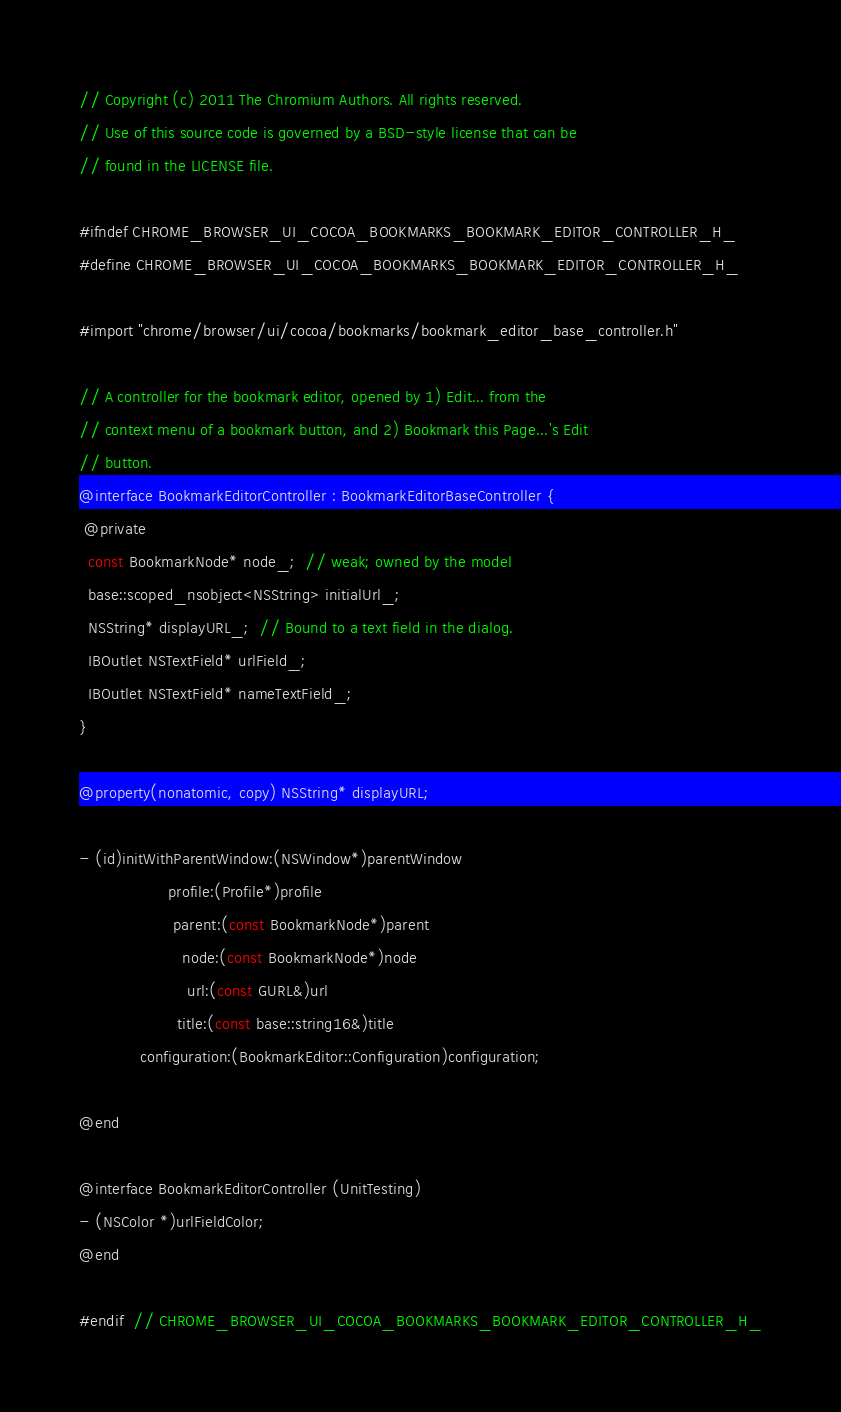Convert code to text. <code><loc_0><loc_0><loc_500><loc_500><_C_>// Copyright (c) 2011 The Chromium Authors. All rights reserved.
// Use of this source code is governed by a BSD-style license that can be
// found in the LICENSE file.

#ifndef CHROME_BROWSER_UI_COCOA_BOOKMARKS_BOOKMARK_EDITOR_CONTROLLER_H_
#define CHROME_BROWSER_UI_COCOA_BOOKMARKS_BOOKMARK_EDITOR_CONTROLLER_H_

#import "chrome/browser/ui/cocoa/bookmarks/bookmark_editor_base_controller.h"

// A controller for the bookmark editor, opened by 1) Edit... from the
// context menu of a bookmark button, and 2) Bookmark this Page...'s Edit
// button.
@interface BookmarkEditorController : BookmarkEditorBaseController {
 @private
  const BookmarkNode* node_;  // weak; owned by the model
  base::scoped_nsobject<NSString> initialUrl_;
  NSString* displayURL_;  // Bound to a text field in the dialog.
  IBOutlet NSTextField* urlField_;
  IBOutlet NSTextField* nameTextField_;
}

@property(nonatomic, copy) NSString* displayURL;

- (id)initWithParentWindow:(NSWindow*)parentWindow
                   profile:(Profile*)profile
                    parent:(const BookmarkNode*)parent
                      node:(const BookmarkNode*)node
                       url:(const GURL&)url
                     title:(const base::string16&)title
             configuration:(BookmarkEditor::Configuration)configuration;

@end

@interface BookmarkEditorController (UnitTesting)
- (NSColor *)urlFieldColor;
@end

#endif  // CHROME_BROWSER_UI_COCOA_BOOKMARKS_BOOKMARK_EDITOR_CONTROLLER_H_
</code> 